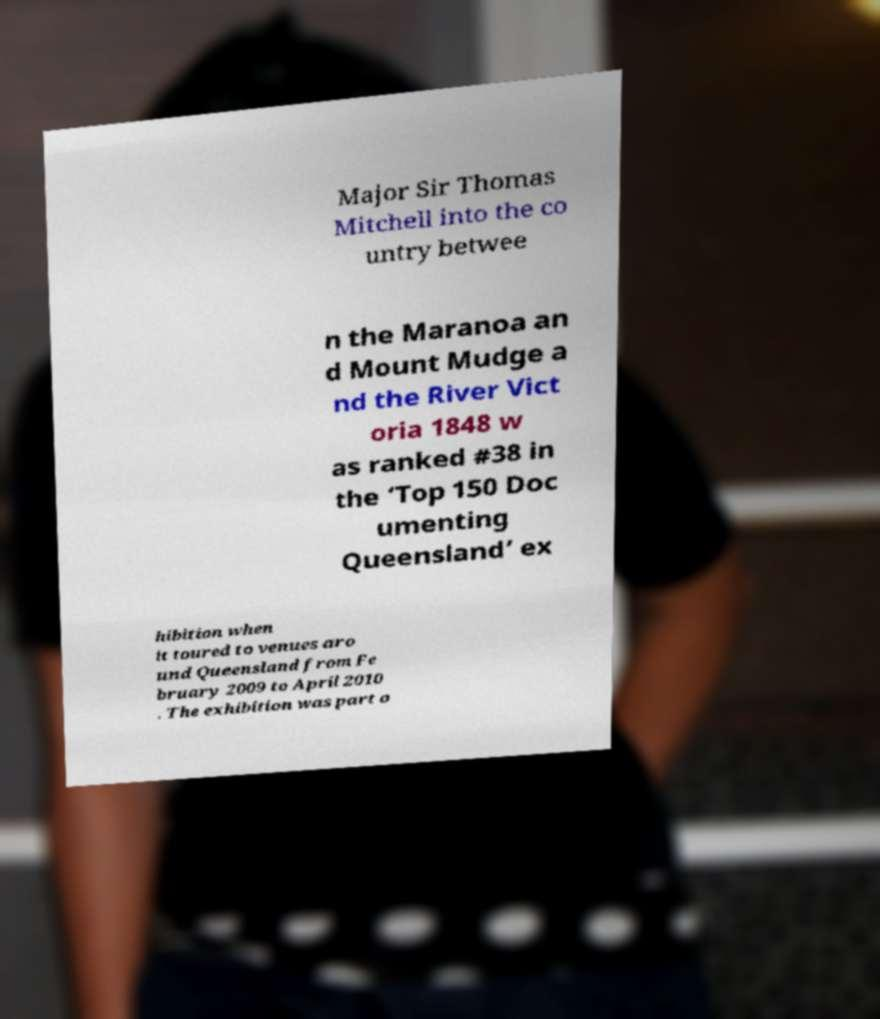Could you assist in decoding the text presented in this image and type it out clearly? Major Sir Thomas Mitchell into the co untry betwee n the Maranoa an d Mount Mudge a nd the River Vict oria 1848 w as ranked #38 in the ‘Top 150 Doc umenting Queensland’ ex hibition when it toured to venues aro und Queensland from Fe bruary 2009 to April 2010 . The exhibition was part o 